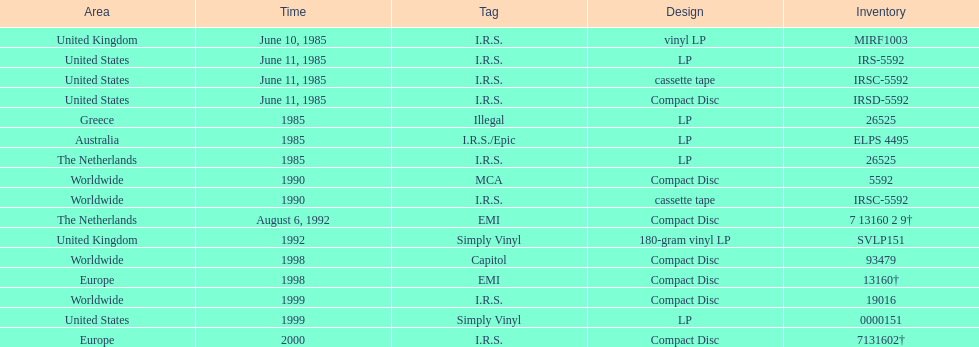Which region has more than one format? United States. 